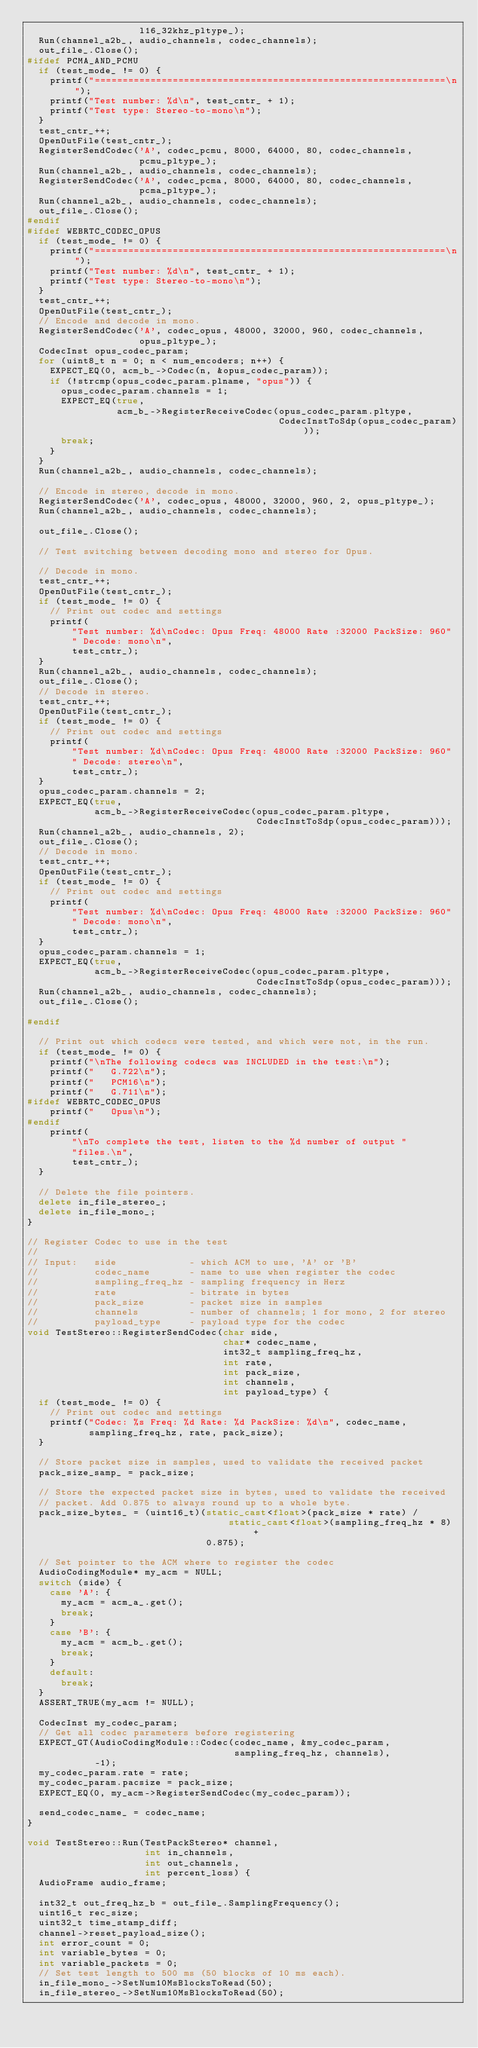<code> <loc_0><loc_0><loc_500><loc_500><_C++_>                    l16_32khz_pltype_);
  Run(channel_a2b_, audio_channels, codec_channels);
  out_file_.Close();
#ifdef PCMA_AND_PCMU
  if (test_mode_ != 0) {
    printf("===============================================================\n");
    printf("Test number: %d\n", test_cntr_ + 1);
    printf("Test type: Stereo-to-mono\n");
  }
  test_cntr_++;
  OpenOutFile(test_cntr_);
  RegisterSendCodec('A', codec_pcmu, 8000, 64000, 80, codec_channels,
                    pcmu_pltype_);
  Run(channel_a2b_, audio_channels, codec_channels);
  RegisterSendCodec('A', codec_pcma, 8000, 64000, 80, codec_channels,
                    pcma_pltype_);
  Run(channel_a2b_, audio_channels, codec_channels);
  out_file_.Close();
#endif
#ifdef WEBRTC_CODEC_OPUS
  if (test_mode_ != 0) {
    printf("===============================================================\n");
    printf("Test number: %d\n", test_cntr_ + 1);
    printf("Test type: Stereo-to-mono\n");
  }
  test_cntr_++;
  OpenOutFile(test_cntr_);
  // Encode and decode in mono.
  RegisterSendCodec('A', codec_opus, 48000, 32000, 960, codec_channels,
                    opus_pltype_);
  CodecInst opus_codec_param;
  for (uint8_t n = 0; n < num_encoders; n++) {
    EXPECT_EQ(0, acm_b_->Codec(n, &opus_codec_param));
    if (!strcmp(opus_codec_param.plname, "opus")) {
      opus_codec_param.channels = 1;
      EXPECT_EQ(true,
                acm_b_->RegisterReceiveCodec(opus_codec_param.pltype,
                                             CodecInstToSdp(opus_codec_param)));
      break;
    }
  }
  Run(channel_a2b_, audio_channels, codec_channels);

  // Encode in stereo, decode in mono.
  RegisterSendCodec('A', codec_opus, 48000, 32000, 960, 2, opus_pltype_);
  Run(channel_a2b_, audio_channels, codec_channels);

  out_file_.Close();

  // Test switching between decoding mono and stereo for Opus.

  // Decode in mono.
  test_cntr_++;
  OpenOutFile(test_cntr_);
  if (test_mode_ != 0) {
    // Print out codec and settings
    printf(
        "Test number: %d\nCodec: Opus Freq: 48000 Rate :32000 PackSize: 960"
        " Decode: mono\n",
        test_cntr_);
  }
  Run(channel_a2b_, audio_channels, codec_channels);
  out_file_.Close();
  // Decode in stereo.
  test_cntr_++;
  OpenOutFile(test_cntr_);
  if (test_mode_ != 0) {
    // Print out codec and settings
    printf(
        "Test number: %d\nCodec: Opus Freq: 48000 Rate :32000 PackSize: 960"
        " Decode: stereo\n",
        test_cntr_);
  }
  opus_codec_param.channels = 2;
  EXPECT_EQ(true,
            acm_b_->RegisterReceiveCodec(opus_codec_param.pltype,
                                         CodecInstToSdp(opus_codec_param)));
  Run(channel_a2b_, audio_channels, 2);
  out_file_.Close();
  // Decode in mono.
  test_cntr_++;
  OpenOutFile(test_cntr_);
  if (test_mode_ != 0) {
    // Print out codec and settings
    printf(
        "Test number: %d\nCodec: Opus Freq: 48000 Rate :32000 PackSize: 960"
        " Decode: mono\n",
        test_cntr_);
  }
  opus_codec_param.channels = 1;
  EXPECT_EQ(true,
            acm_b_->RegisterReceiveCodec(opus_codec_param.pltype,
                                         CodecInstToSdp(opus_codec_param)));
  Run(channel_a2b_, audio_channels, codec_channels);
  out_file_.Close();

#endif

  // Print out which codecs were tested, and which were not, in the run.
  if (test_mode_ != 0) {
    printf("\nThe following codecs was INCLUDED in the test:\n");
    printf("   G.722\n");
    printf("   PCM16\n");
    printf("   G.711\n");
#ifdef WEBRTC_CODEC_OPUS
    printf("   Opus\n");
#endif
    printf(
        "\nTo complete the test, listen to the %d number of output "
        "files.\n",
        test_cntr_);
  }

  // Delete the file pointers.
  delete in_file_stereo_;
  delete in_file_mono_;
}

// Register Codec to use in the test
//
// Input:   side             - which ACM to use, 'A' or 'B'
//          codec_name       - name to use when register the codec
//          sampling_freq_hz - sampling frequency in Herz
//          rate             - bitrate in bytes
//          pack_size        - packet size in samples
//          channels         - number of channels; 1 for mono, 2 for stereo
//          payload_type     - payload type for the codec
void TestStereo::RegisterSendCodec(char side,
                                   char* codec_name,
                                   int32_t sampling_freq_hz,
                                   int rate,
                                   int pack_size,
                                   int channels,
                                   int payload_type) {
  if (test_mode_ != 0) {
    // Print out codec and settings
    printf("Codec: %s Freq: %d Rate: %d PackSize: %d\n", codec_name,
           sampling_freq_hz, rate, pack_size);
  }

  // Store packet size in samples, used to validate the received packet
  pack_size_samp_ = pack_size;

  // Store the expected packet size in bytes, used to validate the received
  // packet. Add 0.875 to always round up to a whole byte.
  pack_size_bytes_ = (uint16_t)(static_cast<float>(pack_size * rate) /
                                    static_cast<float>(sampling_freq_hz * 8) +
                                0.875);

  // Set pointer to the ACM where to register the codec
  AudioCodingModule* my_acm = NULL;
  switch (side) {
    case 'A': {
      my_acm = acm_a_.get();
      break;
    }
    case 'B': {
      my_acm = acm_b_.get();
      break;
    }
    default:
      break;
  }
  ASSERT_TRUE(my_acm != NULL);

  CodecInst my_codec_param;
  // Get all codec parameters before registering
  EXPECT_GT(AudioCodingModule::Codec(codec_name, &my_codec_param,
                                     sampling_freq_hz, channels),
            -1);
  my_codec_param.rate = rate;
  my_codec_param.pacsize = pack_size;
  EXPECT_EQ(0, my_acm->RegisterSendCodec(my_codec_param));

  send_codec_name_ = codec_name;
}

void TestStereo::Run(TestPackStereo* channel,
                     int in_channels,
                     int out_channels,
                     int percent_loss) {
  AudioFrame audio_frame;

  int32_t out_freq_hz_b = out_file_.SamplingFrequency();
  uint16_t rec_size;
  uint32_t time_stamp_diff;
  channel->reset_payload_size();
  int error_count = 0;
  int variable_bytes = 0;
  int variable_packets = 0;
  // Set test length to 500 ms (50 blocks of 10 ms each).
  in_file_mono_->SetNum10MsBlocksToRead(50);
  in_file_stereo_->SetNum10MsBlocksToRead(50);</code> 